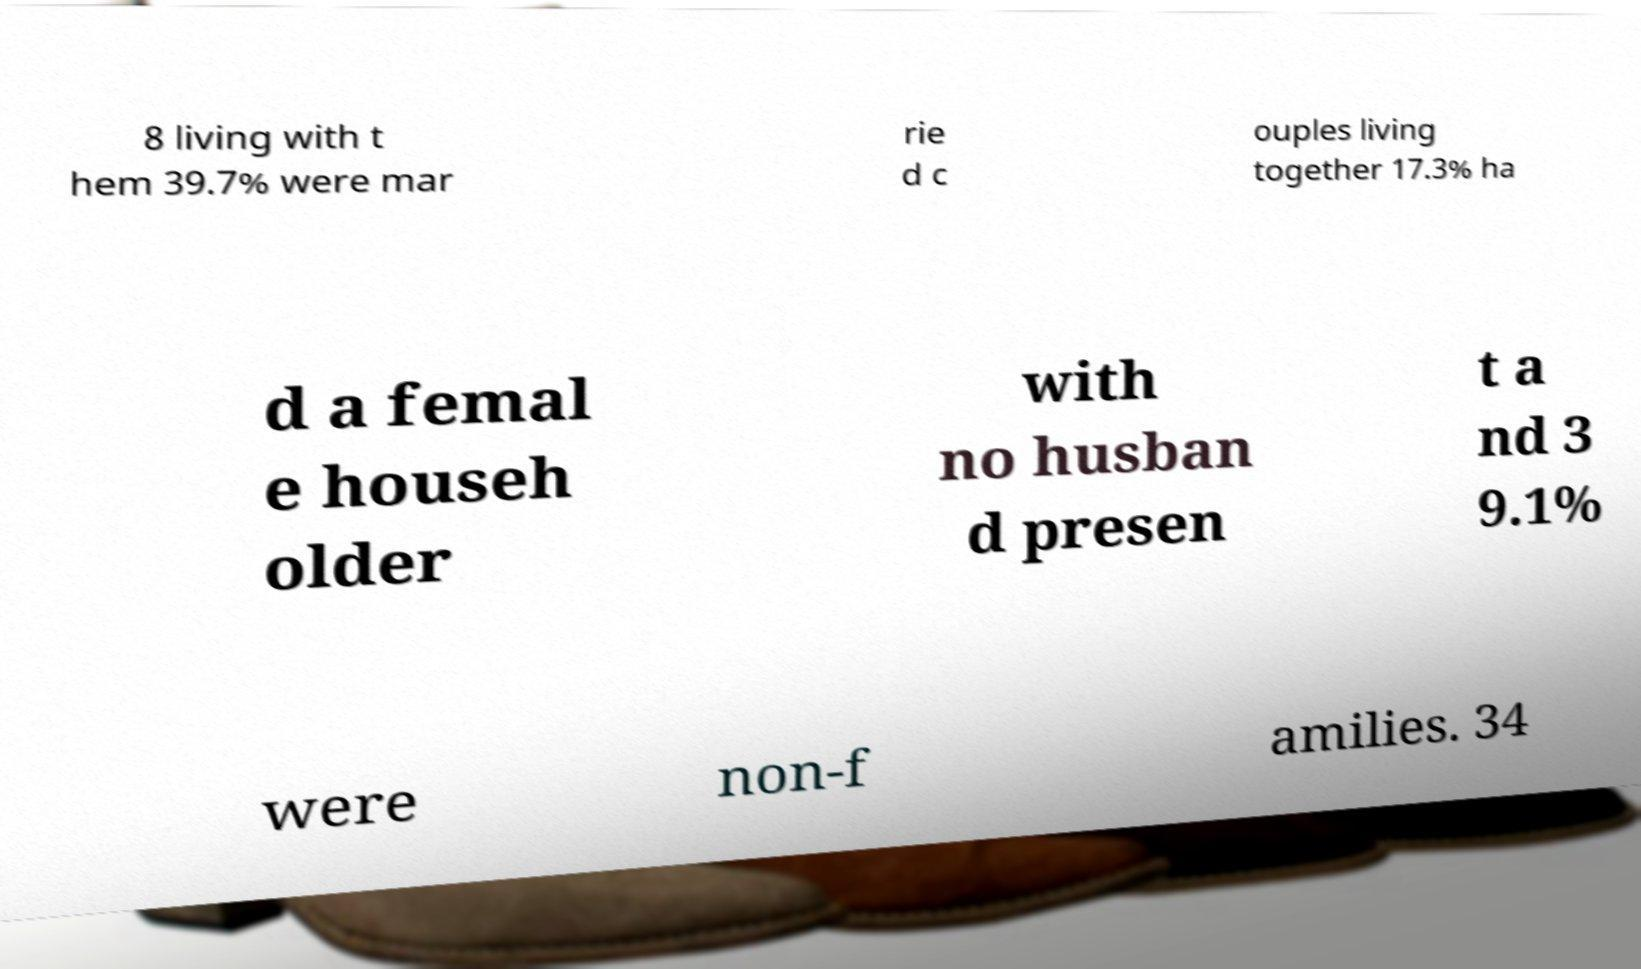For documentation purposes, I need the text within this image transcribed. Could you provide that? 8 living with t hem 39.7% were mar rie d c ouples living together 17.3% ha d a femal e househ older with no husban d presen t a nd 3 9.1% were non-f amilies. 34 